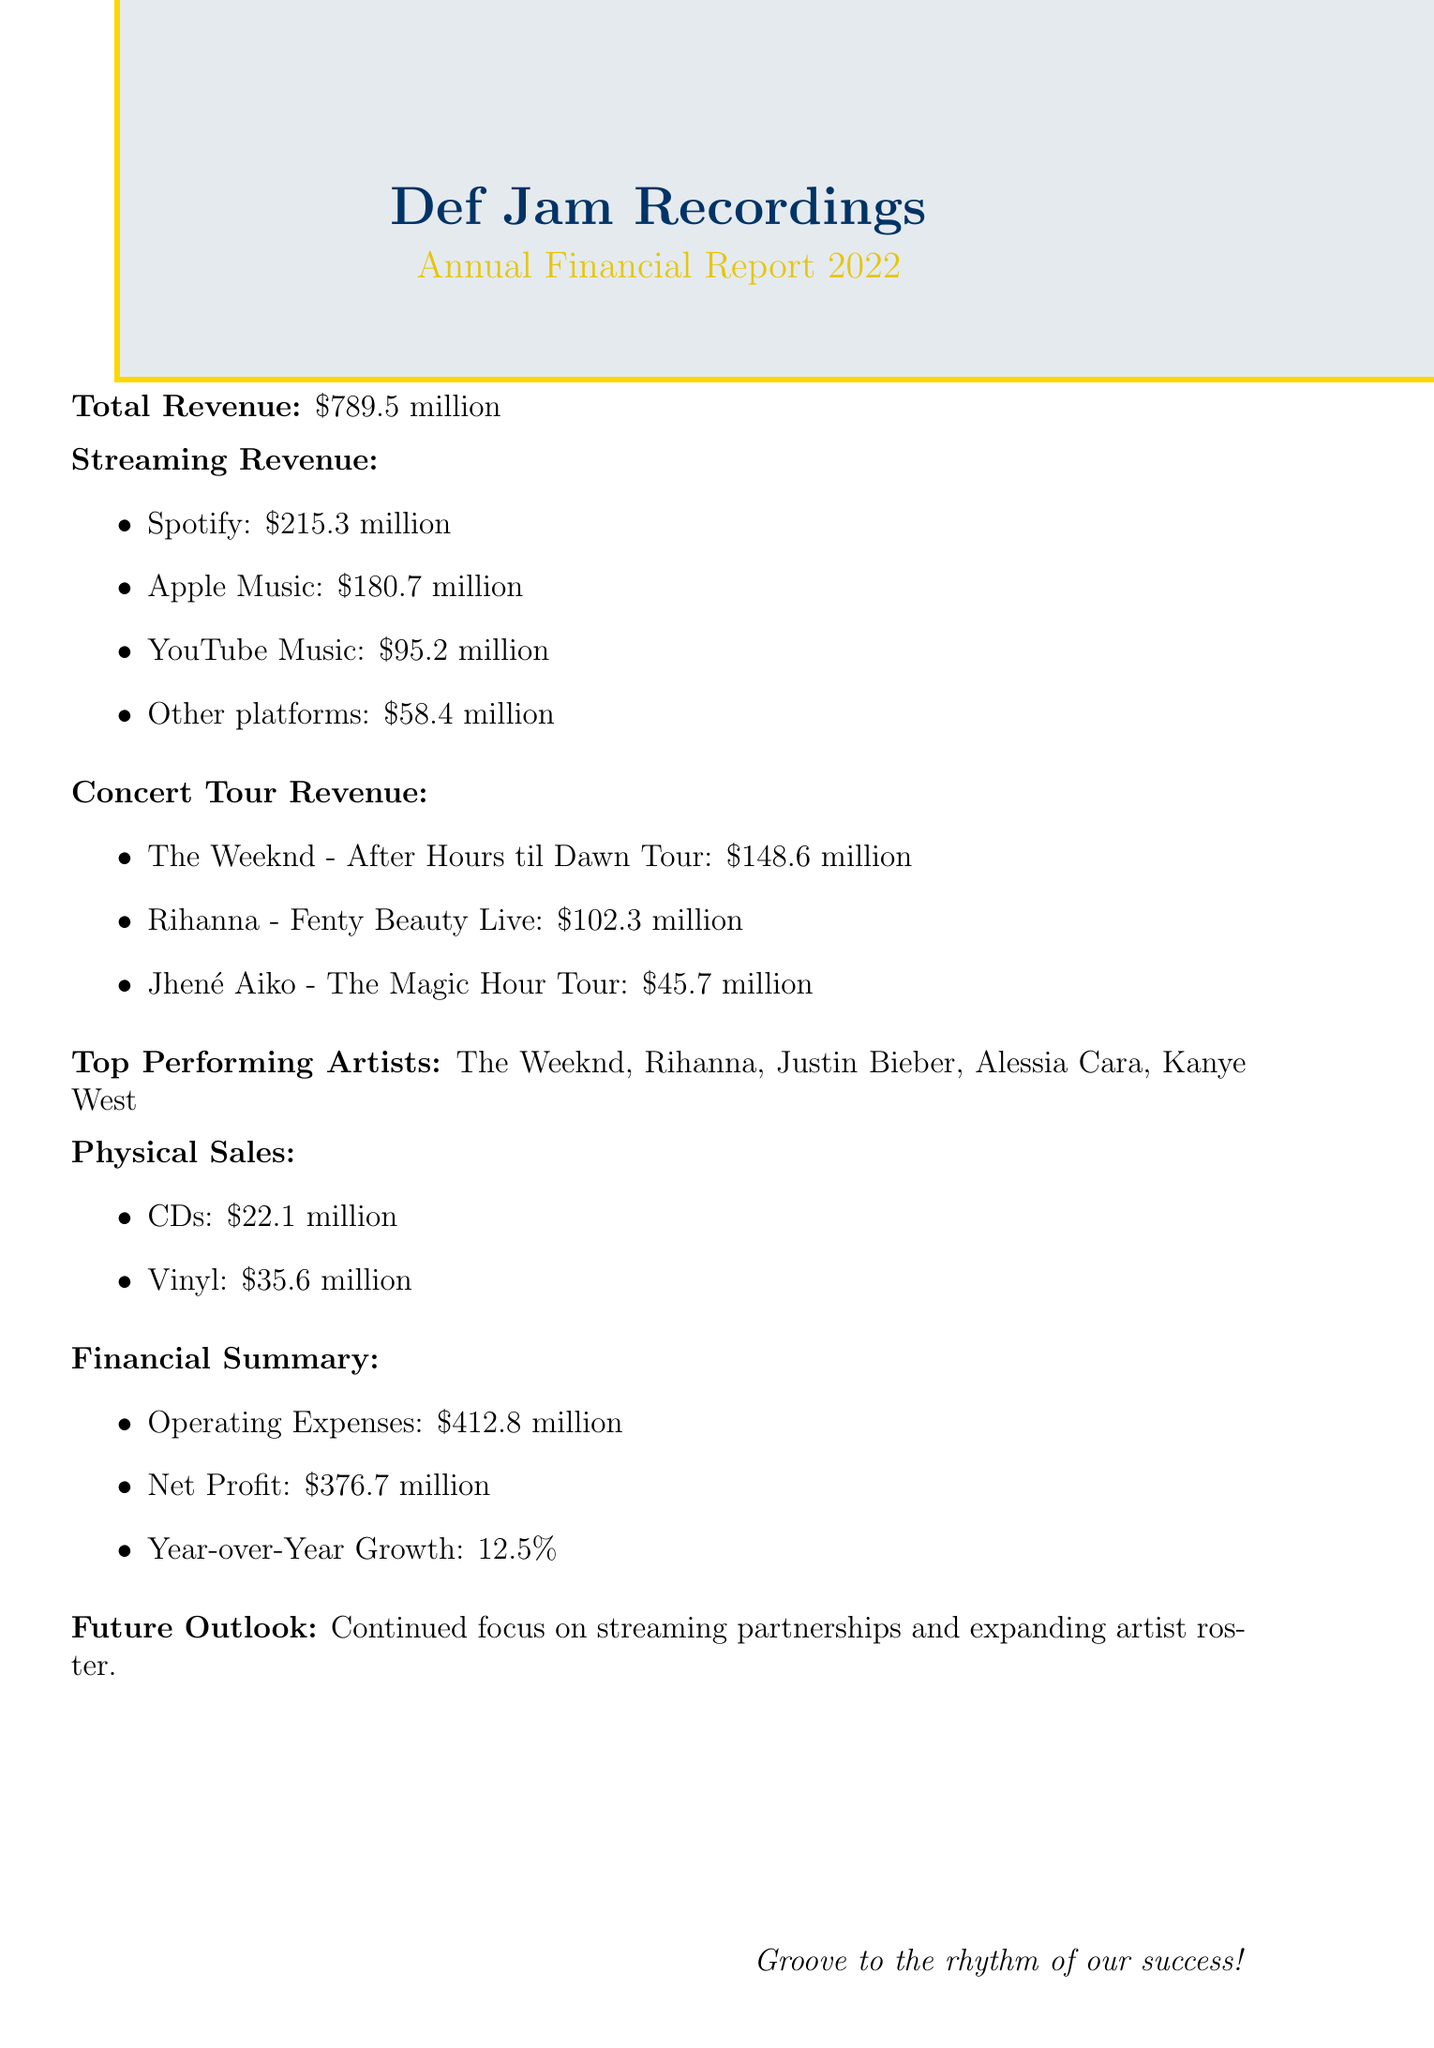What is the total revenue? The total revenue is stated in the document as $789.5 million.
Answer: $789.5 million Which artist generated the highest concert tour revenue? The document lists concert tour revenues, and the highest is from The Weeknd's tour.
Answer: The Weeknd - After Hours til Dawn Tour What was the revenue from Apple Music? The document specifies that Apple Music generated $180.7 million in revenue.
Answer: $180.7 million What is the year-over-year growth percentage? The document mentions a year-over-year growth of 12.5%.
Answer: 12.5% How much did physical CD sales generate? The physical sales section of the document states CDs generated $22.1 million.
Answer: $22.1 million Which platform had the lowest streaming revenue? The streaming revenue lists, and Other platforms is the lowest at $58.4 million.
Answer: Other platforms What was the net profit for the fiscal year? The document clearly states the net profit as $376.7 million.
Answer: $376.7 million How much revenue did Rihanna's tour generate? The document provides concert tour revenue and specifies Rihanna’s tour generated $102.3 million.
Answer: $102.3 million What is the company's future outlook? The document mentions a continued focus on streaming partnerships and expanding artist roster.
Answer: Continued focus on streaming partnerships and expanding artist roster 